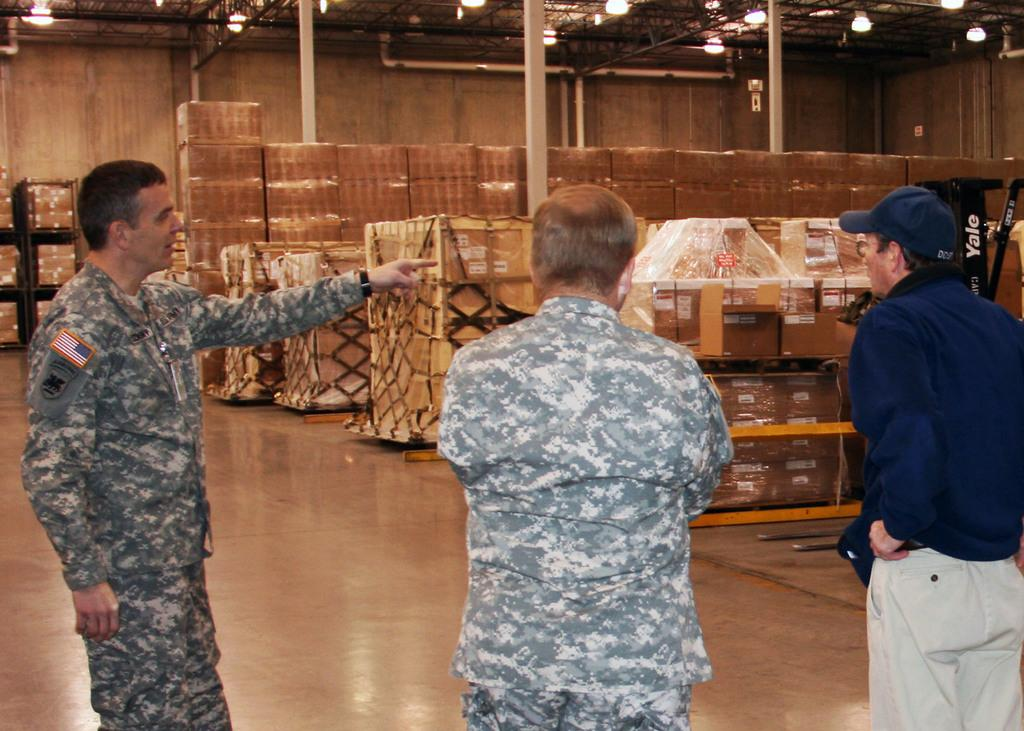How many people are present in the image? There are three people standing in the image. What is the surface on which the people are standing? The people are standing on the floor. What type of objects can be seen arranged in the background? There are boxes arranged in racks in the image. What is visible on top in the image? There are lights visible on top in the image. What caption is written on the box in the image? There is no caption written on the box in the image; the boxes are arranged in racks without any visible text. 